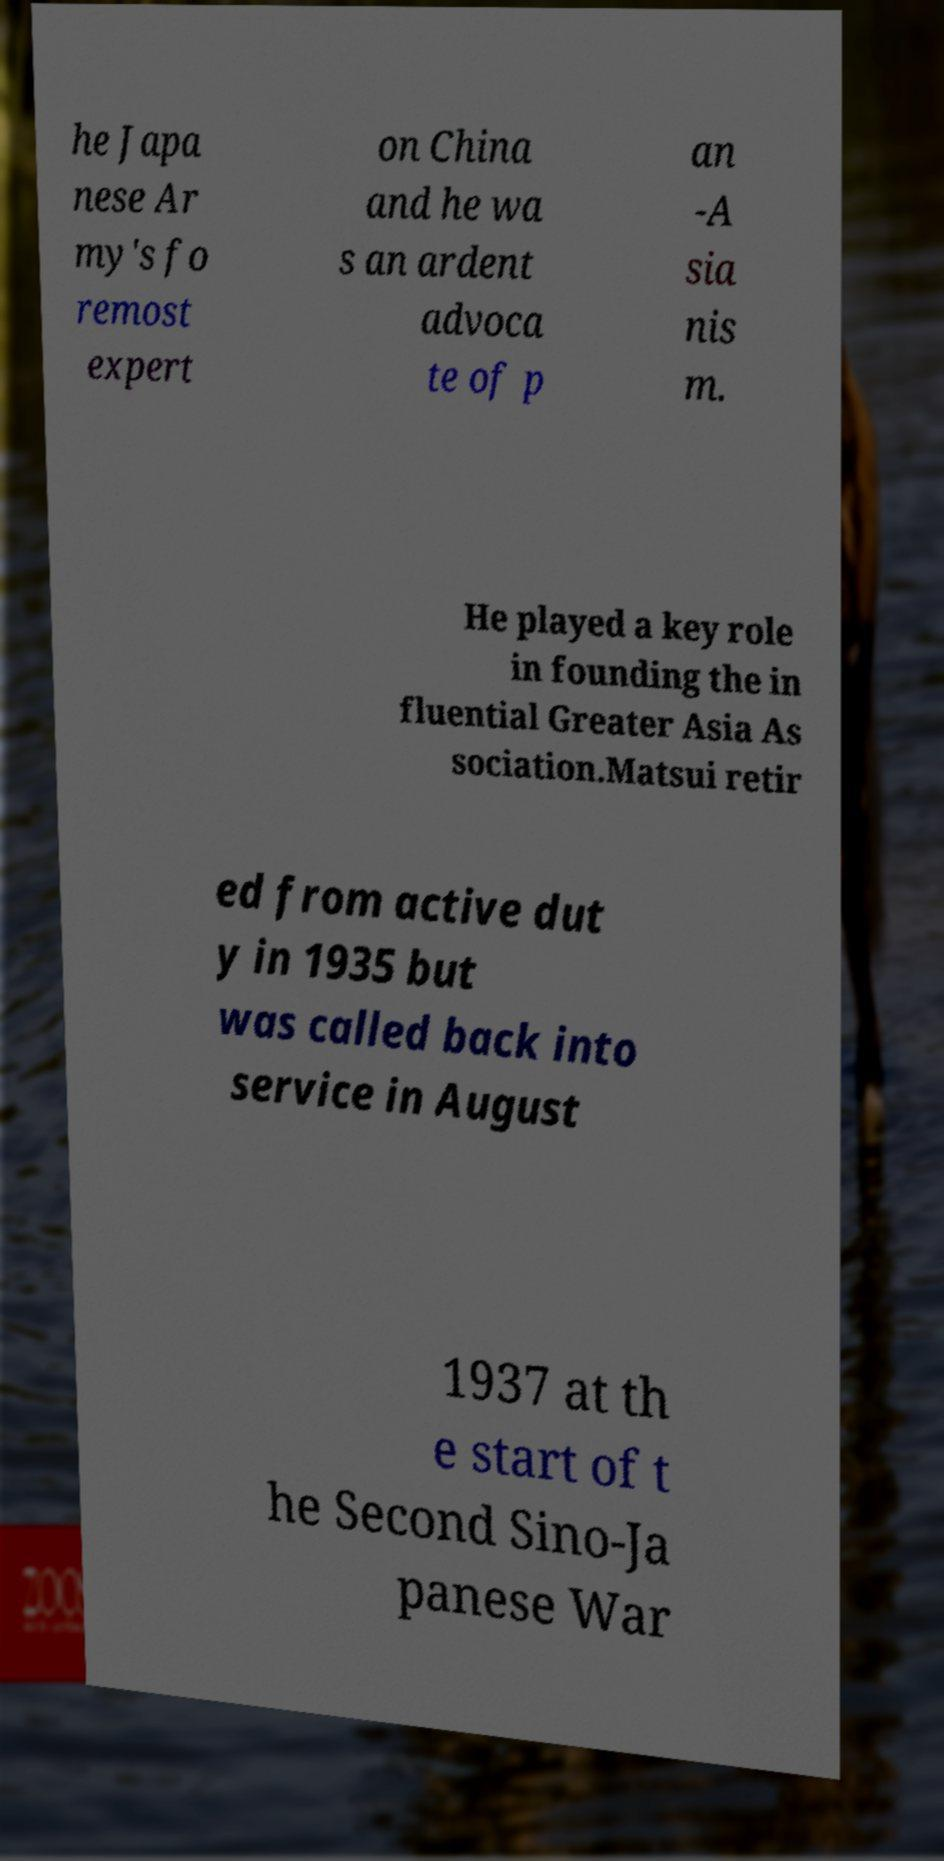There's text embedded in this image that I need extracted. Can you transcribe it verbatim? he Japa nese Ar my's fo remost expert on China and he wa s an ardent advoca te of p an -A sia nis m. He played a key role in founding the in fluential Greater Asia As sociation.Matsui retir ed from active dut y in 1935 but was called back into service in August 1937 at th e start of t he Second Sino-Ja panese War 